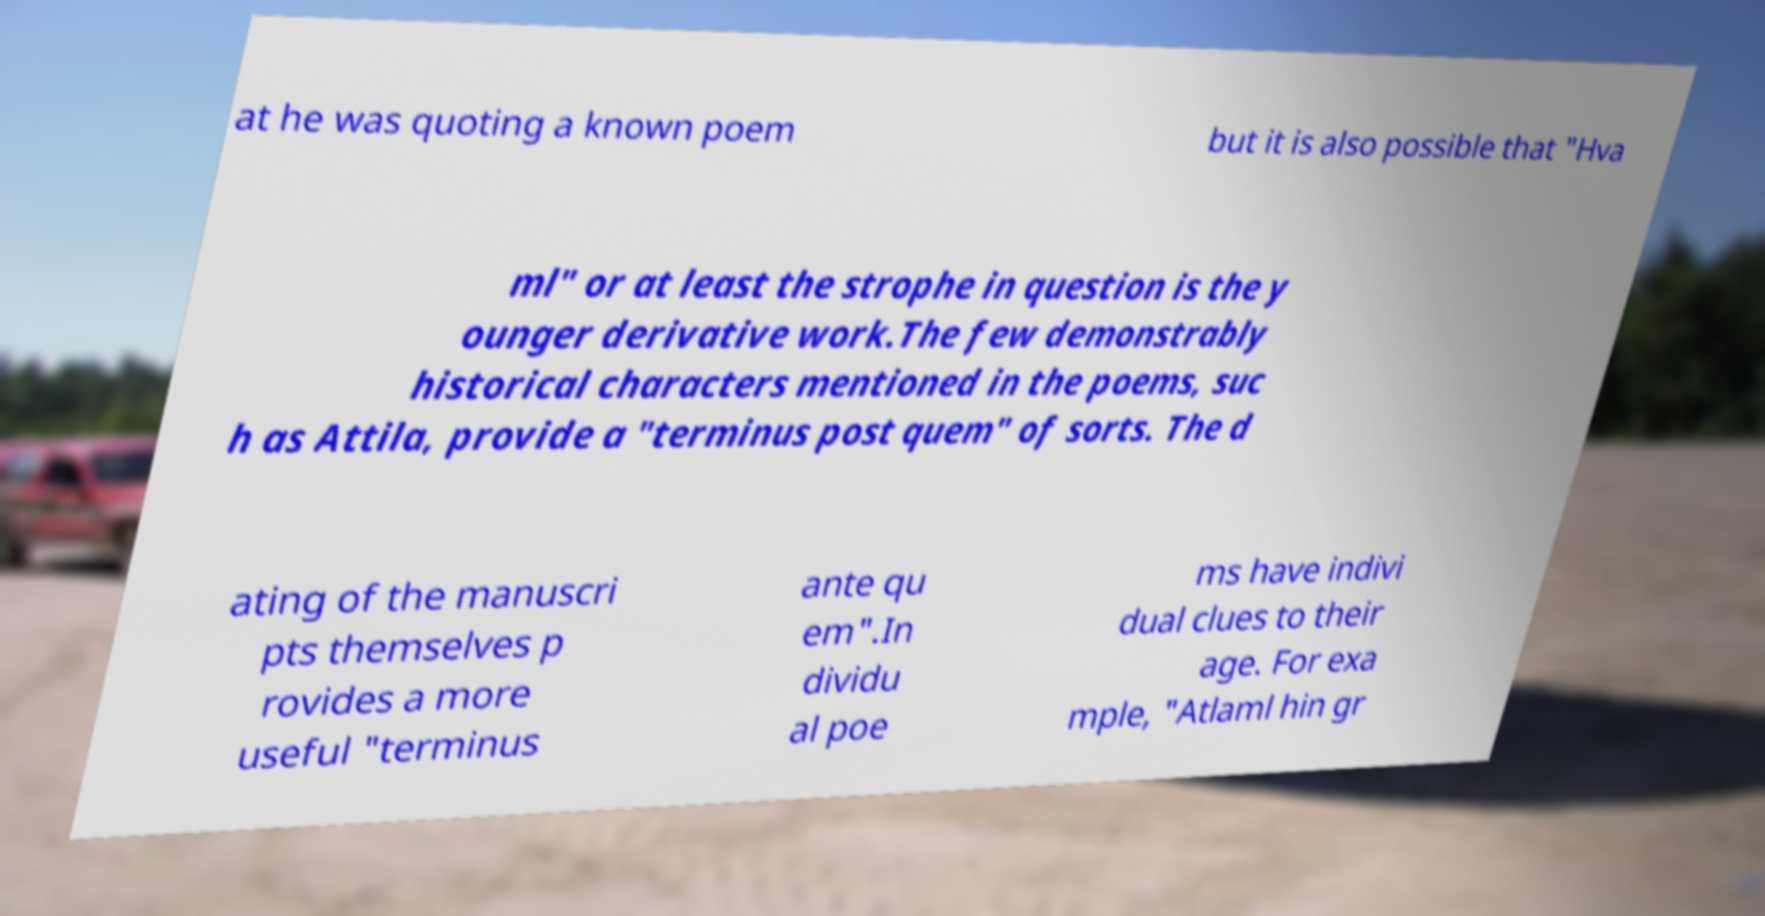Could you extract and type out the text from this image? at he was quoting a known poem but it is also possible that "Hva ml" or at least the strophe in question is the y ounger derivative work.The few demonstrably historical characters mentioned in the poems, suc h as Attila, provide a "terminus post quem" of sorts. The d ating of the manuscri pts themselves p rovides a more useful "terminus ante qu em".In dividu al poe ms have indivi dual clues to their age. For exa mple, "Atlaml hin gr 